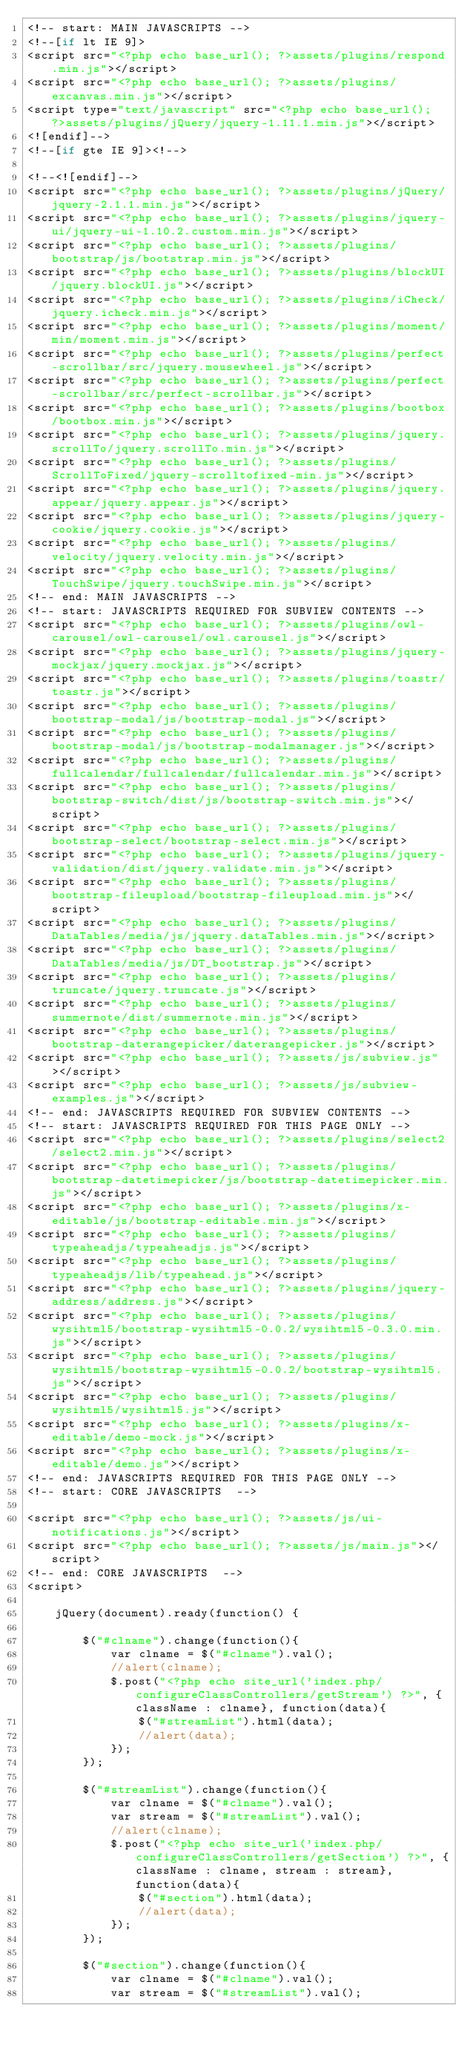<code> <loc_0><loc_0><loc_500><loc_500><_PHP_><!-- start: MAIN JAVASCRIPTS -->
<!--[if lt IE 9]>
<script src="<?php echo base_url(); ?>assets/plugins/respond.min.js"></script>
<script src="<?php echo base_url(); ?>assets/plugins/excanvas.min.js"></script>
<script type="text/javascript" src="<?php echo base_url(); ?>assets/plugins/jQuery/jquery-1.11.1.min.js"></script>
<![endif]-->
<!--[if gte IE 9]><!-->

<!--<![endif]-->
<script src="<?php echo base_url(); ?>assets/plugins/jQuery/jquery-2.1.1.min.js"></script>
<script src="<?php echo base_url(); ?>assets/plugins/jquery-ui/jquery-ui-1.10.2.custom.min.js"></script>
<script src="<?php echo base_url(); ?>assets/plugins/bootstrap/js/bootstrap.min.js"></script>
<script src="<?php echo base_url(); ?>assets/plugins/blockUI/jquery.blockUI.js"></script>
<script src="<?php echo base_url(); ?>assets/plugins/iCheck/jquery.icheck.min.js"></script>
<script src="<?php echo base_url(); ?>assets/plugins/moment/min/moment.min.js"></script>
<script src="<?php echo base_url(); ?>assets/plugins/perfect-scrollbar/src/jquery.mousewheel.js"></script>
<script src="<?php echo base_url(); ?>assets/plugins/perfect-scrollbar/src/perfect-scrollbar.js"></script>
<script src="<?php echo base_url(); ?>assets/plugins/bootbox/bootbox.min.js"></script>
<script src="<?php echo base_url(); ?>assets/plugins/jquery.scrollTo/jquery.scrollTo.min.js"></script>
<script src="<?php echo base_url(); ?>assets/plugins/ScrollToFixed/jquery-scrolltofixed-min.js"></script>
<script src="<?php echo base_url(); ?>assets/plugins/jquery.appear/jquery.appear.js"></script>
<script src="<?php echo base_url(); ?>assets/plugins/jquery-cookie/jquery.cookie.js"></script>
<script src="<?php echo base_url(); ?>assets/plugins/velocity/jquery.velocity.min.js"></script>
<script src="<?php echo base_url(); ?>assets/plugins/TouchSwipe/jquery.touchSwipe.min.js"></script>
<!-- end: MAIN JAVASCRIPTS -->
<!-- start: JAVASCRIPTS REQUIRED FOR SUBVIEW CONTENTS -->
<script src="<?php echo base_url(); ?>assets/plugins/owl-carousel/owl-carousel/owl.carousel.js"></script>
<script src="<?php echo base_url(); ?>assets/plugins/jquery-mockjax/jquery.mockjax.js"></script>
<script src="<?php echo base_url(); ?>assets/plugins/toastr/toastr.js"></script>
<script src="<?php echo base_url(); ?>assets/plugins/bootstrap-modal/js/bootstrap-modal.js"></script>
<script src="<?php echo base_url(); ?>assets/plugins/bootstrap-modal/js/bootstrap-modalmanager.js"></script>
<script src="<?php echo base_url(); ?>assets/plugins/fullcalendar/fullcalendar/fullcalendar.min.js"></script>
<script src="<?php echo base_url(); ?>assets/plugins/bootstrap-switch/dist/js/bootstrap-switch.min.js"></script>
<script src="<?php echo base_url(); ?>assets/plugins/bootstrap-select/bootstrap-select.min.js"></script>
<script src="<?php echo base_url(); ?>assets/plugins/jquery-validation/dist/jquery.validate.min.js"></script>
<script src="<?php echo base_url(); ?>assets/plugins/bootstrap-fileupload/bootstrap-fileupload.min.js"></script>
<script src="<?php echo base_url(); ?>assets/plugins/DataTables/media/js/jquery.dataTables.min.js"></script>
<script src="<?php echo base_url(); ?>assets/plugins/DataTables/media/js/DT_bootstrap.js"></script>
<script src="<?php echo base_url(); ?>assets/plugins/truncate/jquery.truncate.js"></script>
<script src="<?php echo base_url(); ?>assets/plugins/summernote/dist/summernote.min.js"></script>
<script src="<?php echo base_url(); ?>assets/plugins/bootstrap-daterangepicker/daterangepicker.js"></script>
<script src="<?php echo base_url(); ?>assets/js/subview.js"></script>
<script src="<?php echo base_url(); ?>assets/js/subview-examples.js"></script>
<!-- end: JAVASCRIPTS REQUIRED FOR SUBVIEW CONTENTS -->
<!-- start: JAVASCRIPTS REQUIRED FOR THIS PAGE ONLY -->
<script src="<?php echo base_url(); ?>assets/plugins/select2/select2.min.js"></script>
<script src="<?php echo base_url(); ?>assets/plugins/bootstrap-datetimepicker/js/bootstrap-datetimepicker.min.js"></script>
<script src="<?php echo base_url(); ?>assets/plugins/x-editable/js/bootstrap-editable.min.js"></script>
<script src="<?php echo base_url(); ?>assets/plugins/typeaheadjs/typeaheadjs.js"></script>
<script src="<?php echo base_url(); ?>assets/plugins/typeaheadjs/lib/typeahead.js"></script>
<script src="<?php echo base_url(); ?>assets/plugins/jquery-address/address.js"></script>
<script src="<?php echo base_url(); ?>assets/plugins/wysihtml5/bootstrap-wysihtml5-0.0.2/wysihtml5-0.3.0.min.js"></script>
<script src="<?php echo base_url(); ?>assets/plugins/wysihtml5/bootstrap-wysihtml5-0.0.2/bootstrap-wysihtml5.js"></script>
<script src="<?php echo base_url(); ?>assets/plugins/wysihtml5/wysihtml5.js"></script>
<script src="<?php echo base_url(); ?>assets/plugins/x-editable/demo-mock.js"></script>
<script src="<?php echo base_url(); ?>assets/plugins/x-editable/demo.js"></script>
<!-- end: JAVASCRIPTS REQUIRED FOR THIS PAGE ONLY -->
<!-- start: CORE JAVASCRIPTS  -->

<script src="<?php echo base_url(); ?>assets/js/ui-notifications.js"></script>
<script src="<?php echo base_url(); ?>assets/js/main.js"></script>
<!-- end: CORE JAVASCRIPTS  -->
<script>
	
    jQuery(document).ready(function() {

        $("#clname").change(function(){
            var clname = $("#clname").val();
            //alert(clname);
            $.post("<?php echo site_url('index.php/configureClassControllers/getStream') ?>", {className : clname}, function(data){
                $("#streamList").html(data);
                //alert(data);
    		});
        });

        $("#streamList").change(function(){
            var clname = $("#clname").val();
            var stream = $("#streamList").val();
            //alert(clname);
            $.post("<?php echo site_url('index.php/configureClassControllers/getSection') ?>", {className : clname, stream : stream}, function(data){
                $("#section").html(data);
                //alert(data);
    		});
        });

        $("#section").change(function(){
            var clname = $("#clname").val();
            var stream = $("#streamList").val();</code> 